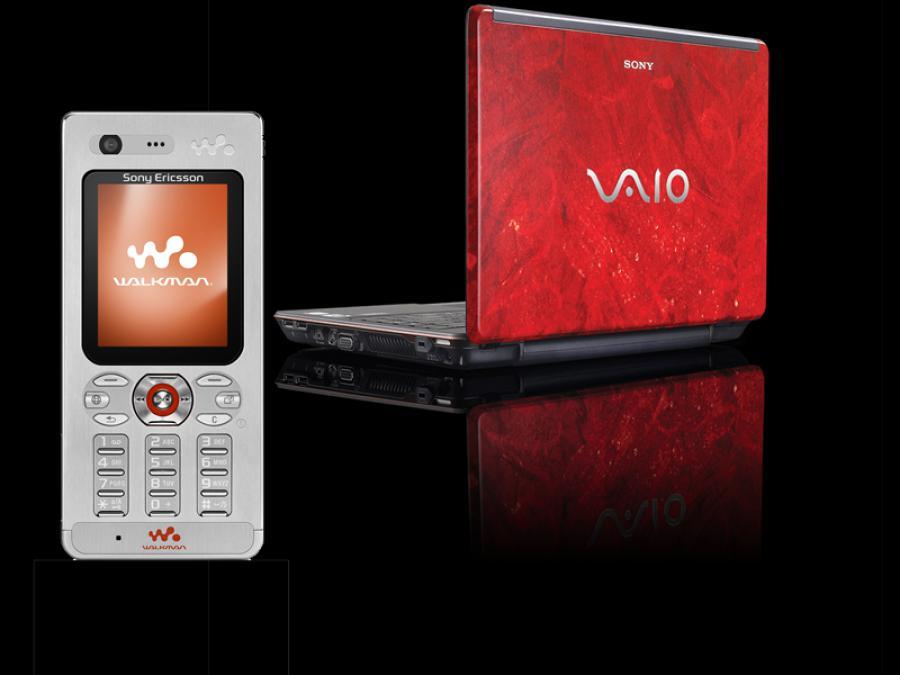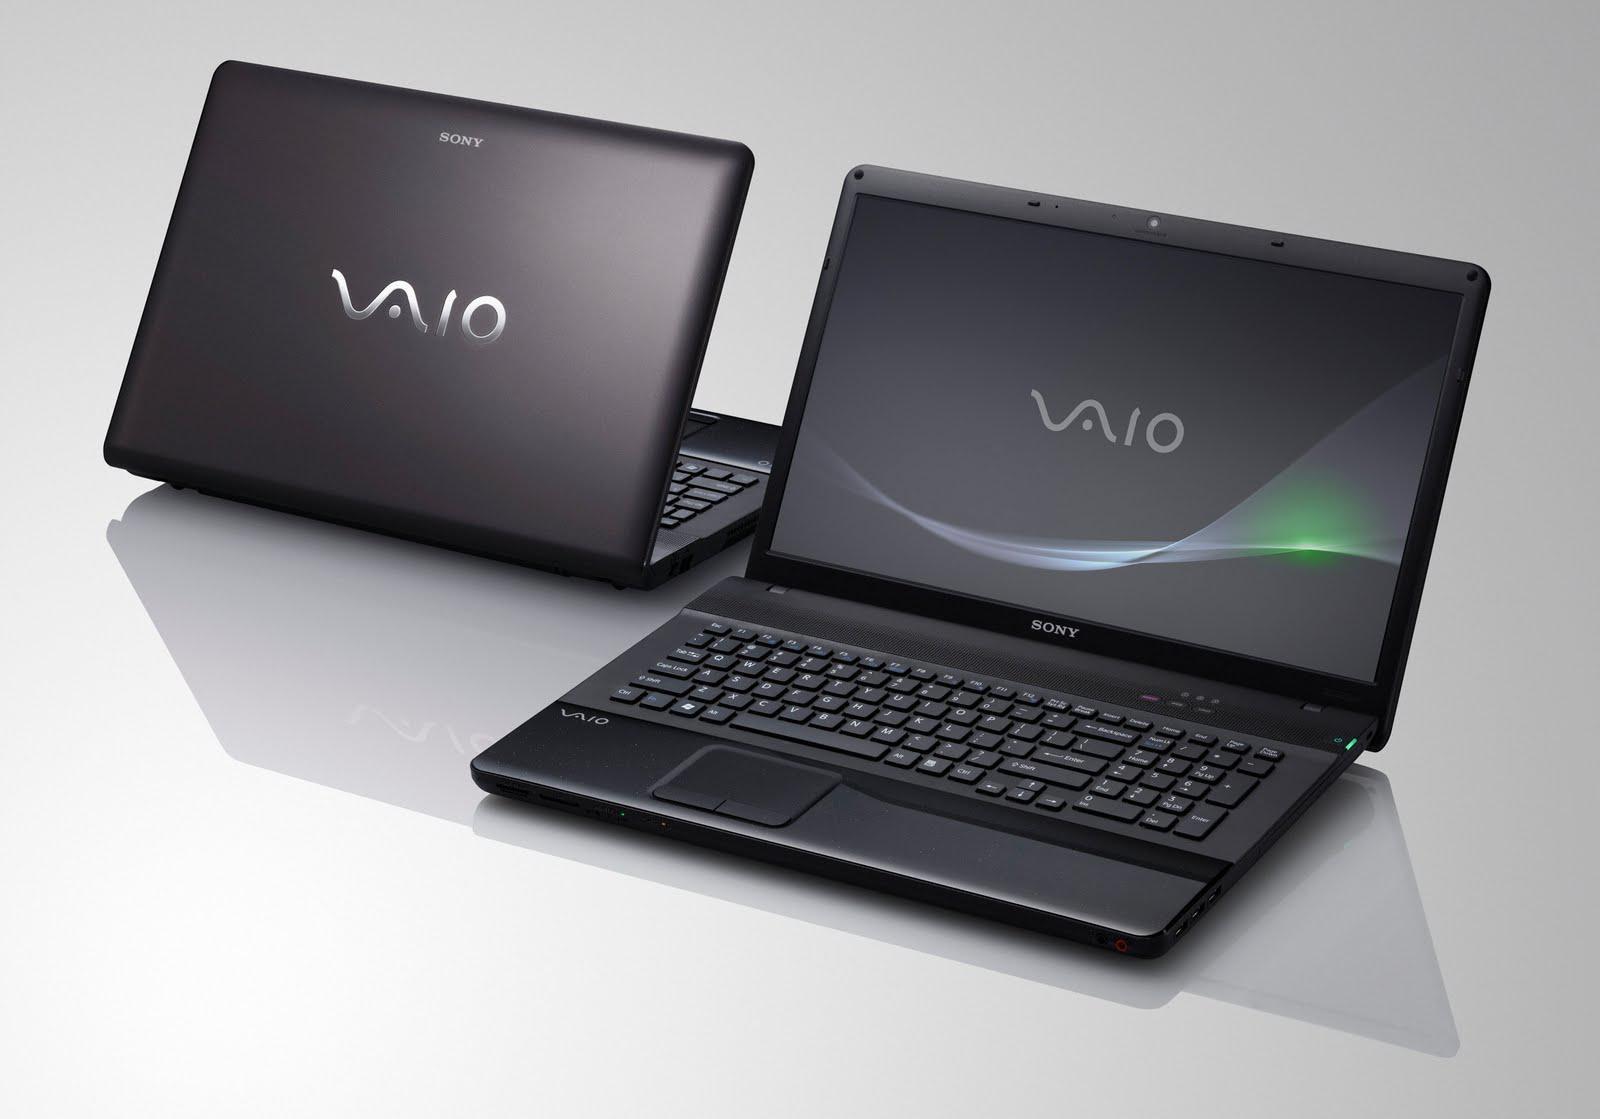The first image is the image on the left, the second image is the image on the right. Given the left and right images, does the statement "The left image shows a screen elevated by a structure on at least one side above a keyboard." hold true? Answer yes or no. No. 